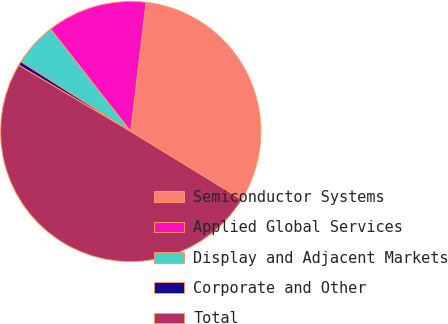Convert chart to OTSL. <chart><loc_0><loc_0><loc_500><loc_500><pie_chart><fcel>Semiconductor Systems<fcel>Applied Global Services<fcel>Display and Adjacent Markets<fcel>Corporate and Other<fcel>Total<nl><fcel>31.86%<fcel>12.44%<fcel>5.43%<fcel>0.5%<fcel>49.78%<nl></chart> 